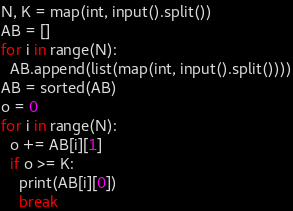Convert code to text. <code><loc_0><loc_0><loc_500><loc_500><_Python_>N, K = map(int, input().split())
AB = []
for i in range(N):
  AB.append(list(map(int, input().split())))
AB = sorted(AB)
o = 0
for i in range(N):
  o += AB[i][1]
  if o >= K:
    print(AB[i][0])
    break</code> 